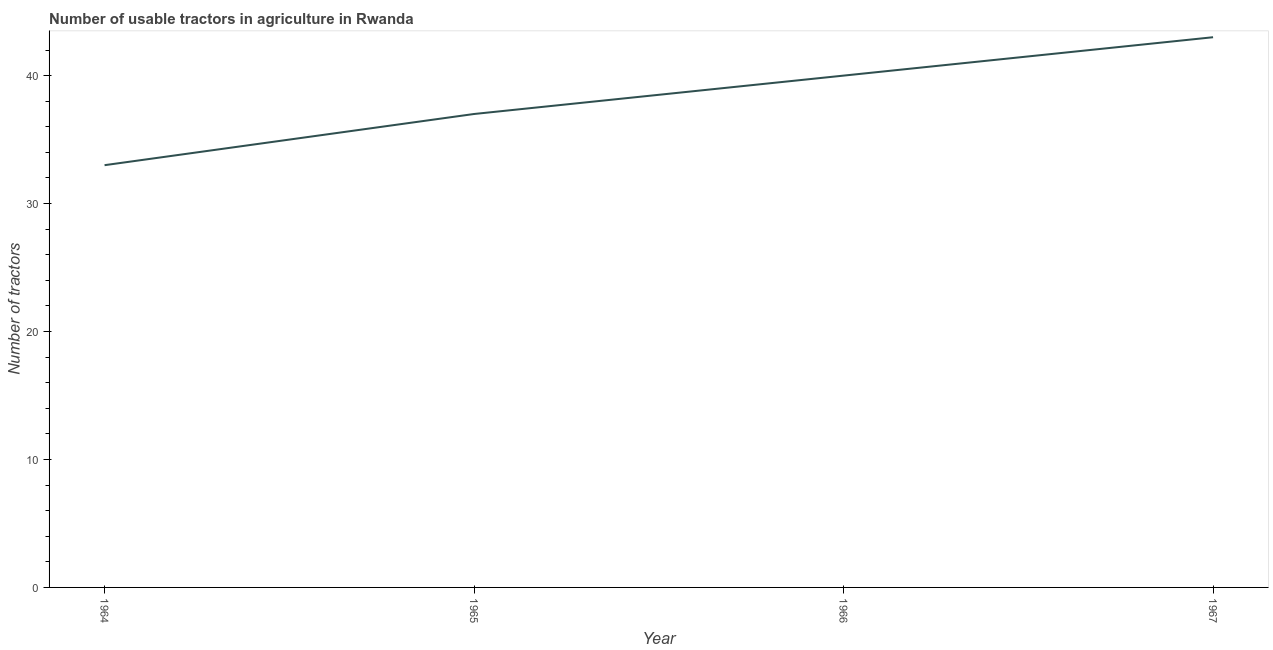What is the number of tractors in 1964?
Offer a very short reply. 33. Across all years, what is the maximum number of tractors?
Provide a short and direct response. 43. Across all years, what is the minimum number of tractors?
Offer a very short reply. 33. In which year was the number of tractors maximum?
Offer a very short reply. 1967. In which year was the number of tractors minimum?
Your answer should be very brief. 1964. What is the sum of the number of tractors?
Ensure brevity in your answer.  153. What is the difference between the number of tractors in 1964 and 1967?
Keep it short and to the point. -10. What is the average number of tractors per year?
Ensure brevity in your answer.  38.25. What is the median number of tractors?
Offer a terse response. 38.5. In how many years, is the number of tractors greater than 4 ?
Your response must be concise. 4. Do a majority of the years between 1964 and 1965 (inclusive) have number of tractors greater than 16 ?
Your response must be concise. Yes. What is the ratio of the number of tractors in 1964 to that in 1965?
Provide a short and direct response. 0.89. Is the number of tractors in 1966 less than that in 1967?
Ensure brevity in your answer.  Yes. What is the difference between the highest and the second highest number of tractors?
Offer a terse response. 3. Is the sum of the number of tractors in 1964 and 1967 greater than the maximum number of tractors across all years?
Provide a succinct answer. Yes. What is the difference between the highest and the lowest number of tractors?
Your answer should be compact. 10. In how many years, is the number of tractors greater than the average number of tractors taken over all years?
Your response must be concise. 2. Does the number of tractors monotonically increase over the years?
Give a very brief answer. Yes. How many lines are there?
Keep it short and to the point. 1. What is the difference between two consecutive major ticks on the Y-axis?
Offer a very short reply. 10. Are the values on the major ticks of Y-axis written in scientific E-notation?
Offer a terse response. No. What is the title of the graph?
Provide a short and direct response. Number of usable tractors in agriculture in Rwanda. What is the label or title of the Y-axis?
Provide a short and direct response. Number of tractors. What is the difference between the Number of tractors in 1964 and 1965?
Your answer should be compact. -4. What is the difference between the Number of tractors in 1965 and 1966?
Ensure brevity in your answer.  -3. What is the difference between the Number of tractors in 1965 and 1967?
Keep it short and to the point. -6. What is the difference between the Number of tractors in 1966 and 1967?
Ensure brevity in your answer.  -3. What is the ratio of the Number of tractors in 1964 to that in 1965?
Make the answer very short. 0.89. What is the ratio of the Number of tractors in 1964 to that in 1966?
Keep it short and to the point. 0.82. What is the ratio of the Number of tractors in 1964 to that in 1967?
Offer a very short reply. 0.77. What is the ratio of the Number of tractors in 1965 to that in 1966?
Make the answer very short. 0.93. What is the ratio of the Number of tractors in 1965 to that in 1967?
Keep it short and to the point. 0.86. What is the ratio of the Number of tractors in 1966 to that in 1967?
Your answer should be compact. 0.93. 